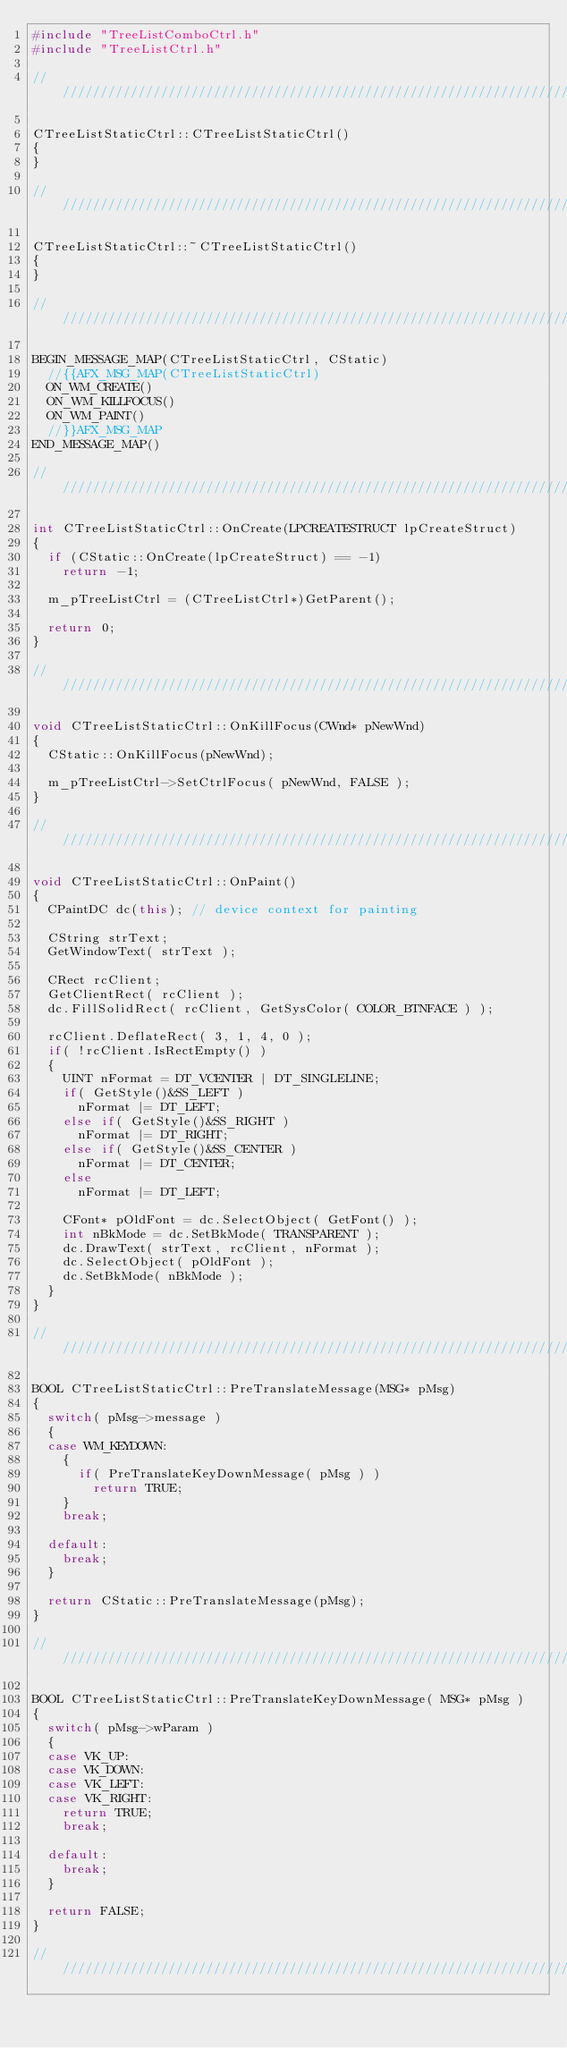Convert code to text. <code><loc_0><loc_0><loc_500><loc_500><_C++_>#include "TreeListComboCtrl.h"
#include "TreeListCtrl.h"

////////////////////////////////////////////////////////////////////////////////

CTreeListStaticCtrl::CTreeListStaticCtrl()
{
}

////////////////////////////////////////////////////////////////////////////////

CTreeListStaticCtrl::~CTreeListStaticCtrl()
{
}

////////////////////////////////////////////////////////////////////////////////

BEGIN_MESSAGE_MAP(CTreeListStaticCtrl, CStatic)
  //{{AFX_MSG_MAP(CTreeListStaticCtrl)
  ON_WM_CREATE()
  ON_WM_KILLFOCUS()
  ON_WM_PAINT()
  //}}AFX_MSG_MAP
END_MESSAGE_MAP()

/////////////////////////////////////////////////////////////////////////////

int CTreeListStaticCtrl::OnCreate(LPCREATESTRUCT lpCreateStruct) 
{
  if (CStatic::OnCreate(lpCreateStruct) == -1)
    return -1;

  m_pTreeListCtrl = (CTreeListCtrl*)GetParent();

  return 0;
}

////////////////////////////////////////////////////////////////////////////////

void CTreeListStaticCtrl::OnKillFocus(CWnd* pNewWnd) 
{
  CStatic::OnKillFocus(pNewWnd);

  m_pTreeListCtrl->SetCtrlFocus( pNewWnd, FALSE );
}

////////////////////////////////////////////////////////////////////////////////

void CTreeListStaticCtrl::OnPaint() 
{
  CPaintDC dc(this); // device context for painting

  CString strText;
  GetWindowText( strText );

  CRect rcClient;
  GetClientRect( rcClient );
  dc.FillSolidRect( rcClient, GetSysColor( COLOR_BTNFACE ) );

  rcClient.DeflateRect( 3, 1, 4, 0 );
  if( !rcClient.IsRectEmpty() )
  {
    UINT nFormat = DT_VCENTER | DT_SINGLELINE;
    if( GetStyle()&SS_LEFT )
      nFormat |= DT_LEFT;
    else if( GetStyle()&SS_RIGHT )
      nFormat |= DT_RIGHT;
    else if( GetStyle()&SS_CENTER )
      nFormat |= DT_CENTER;
    else
      nFormat |= DT_LEFT;

    CFont* pOldFont = dc.SelectObject( GetFont() );
    int nBkMode = dc.SetBkMode( TRANSPARENT );
    dc.DrawText( strText, rcClient, nFormat );
    dc.SelectObject( pOldFont );
    dc.SetBkMode( nBkMode );
  }
}

////////////////////////////////////////////////////////////////////////////////

BOOL CTreeListStaticCtrl::PreTranslateMessage(MSG* pMsg) 
{
  switch( pMsg->message )
  {
  case WM_KEYDOWN:
    {
      if( PreTranslateKeyDownMessage( pMsg ) )
        return TRUE;
    }
    break;

  default:
    break;
  }

  return CStatic::PreTranslateMessage(pMsg);
}

////////////////////////////////////////////////////////////////////////////////

BOOL CTreeListStaticCtrl::PreTranslateKeyDownMessage( MSG* pMsg )
{
  switch( pMsg->wParam )
  {
  case VK_UP:
  case VK_DOWN:
  case VK_LEFT:
  case VK_RIGHT:
    return TRUE;
    break;

  default:
    break;
  }

  return FALSE;
}

////////////////////////////////////////////////////////////////////////////////
</code> 